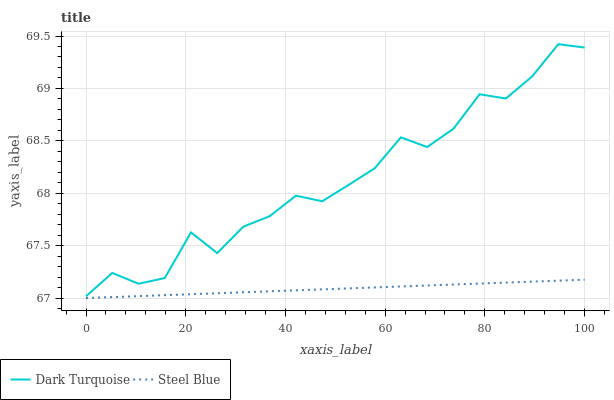Does Steel Blue have the minimum area under the curve?
Answer yes or no. Yes. Does Dark Turquoise have the maximum area under the curve?
Answer yes or no. Yes. Does Steel Blue have the maximum area under the curve?
Answer yes or no. No. Is Steel Blue the smoothest?
Answer yes or no. Yes. Is Dark Turquoise the roughest?
Answer yes or no. Yes. Is Steel Blue the roughest?
Answer yes or no. No. Does Dark Turquoise have the highest value?
Answer yes or no. Yes. Does Steel Blue have the highest value?
Answer yes or no. No. Is Steel Blue less than Dark Turquoise?
Answer yes or no. Yes. Is Dark Turquoise greater than Steel Blue?
Answer yes or no. Yes. Does Steel Blue intersect Dark Turquoise?
Answer yes or no. No. 